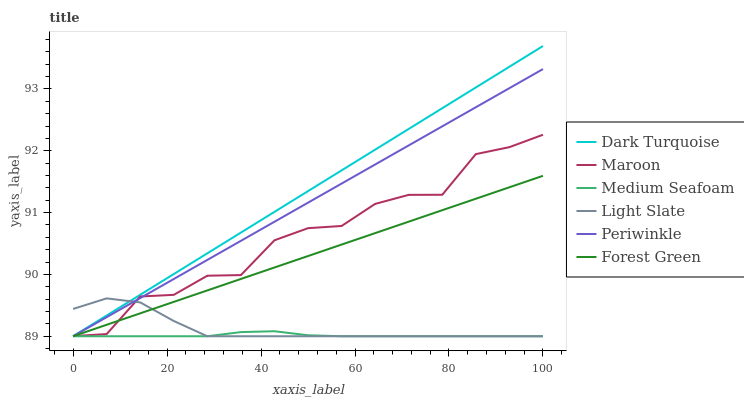Does Medium Seafoam have the minimum area under the curve?
Answer yes or no. Yes. Does Dark Turquoise have the maximum area under the curve?
Answer yes or no. Yes. Does Maroon have the minimum area under the curve?
Answer yes or no. No. Does Maroon have the maximum area under the curve?
Answer yes or no. No. Is Forest Green the smoothest?
Answer yes or no. Yes. Is Maroon the roughest?
Answer yes or no. Yes. Is Dark Turquoise the smoothest?
Answer yes or no. No. Is Dark Turquoise the roughest?
Answer yes or no. No. Does Light Slate have the lowest value?
Answer yes or no. Yes. Does Maroon have the lowest value?
Answer yes or no. No. Does Dark Turquoise have the highest value?
Answer yes or no. Yes. Does Maroon have the highest value?
Answer yes or no. No. Is Medium Seafoam less than Maroon?
Answer yes or no. Yes. Is Maroon greater than Medium Seafoam?
Answer yes or no. Yes. Does Maroon intersect Dark Turquoise?
Answer yes or no. Yes. Is Maroon less than Dark Turquoise?
Answer yes or no. No. Is Maroon greater than Dark Turquoise?
Answer yes or no. No. Does Medium Seafoam intersect Maroon?
Answer yes or no. No. 